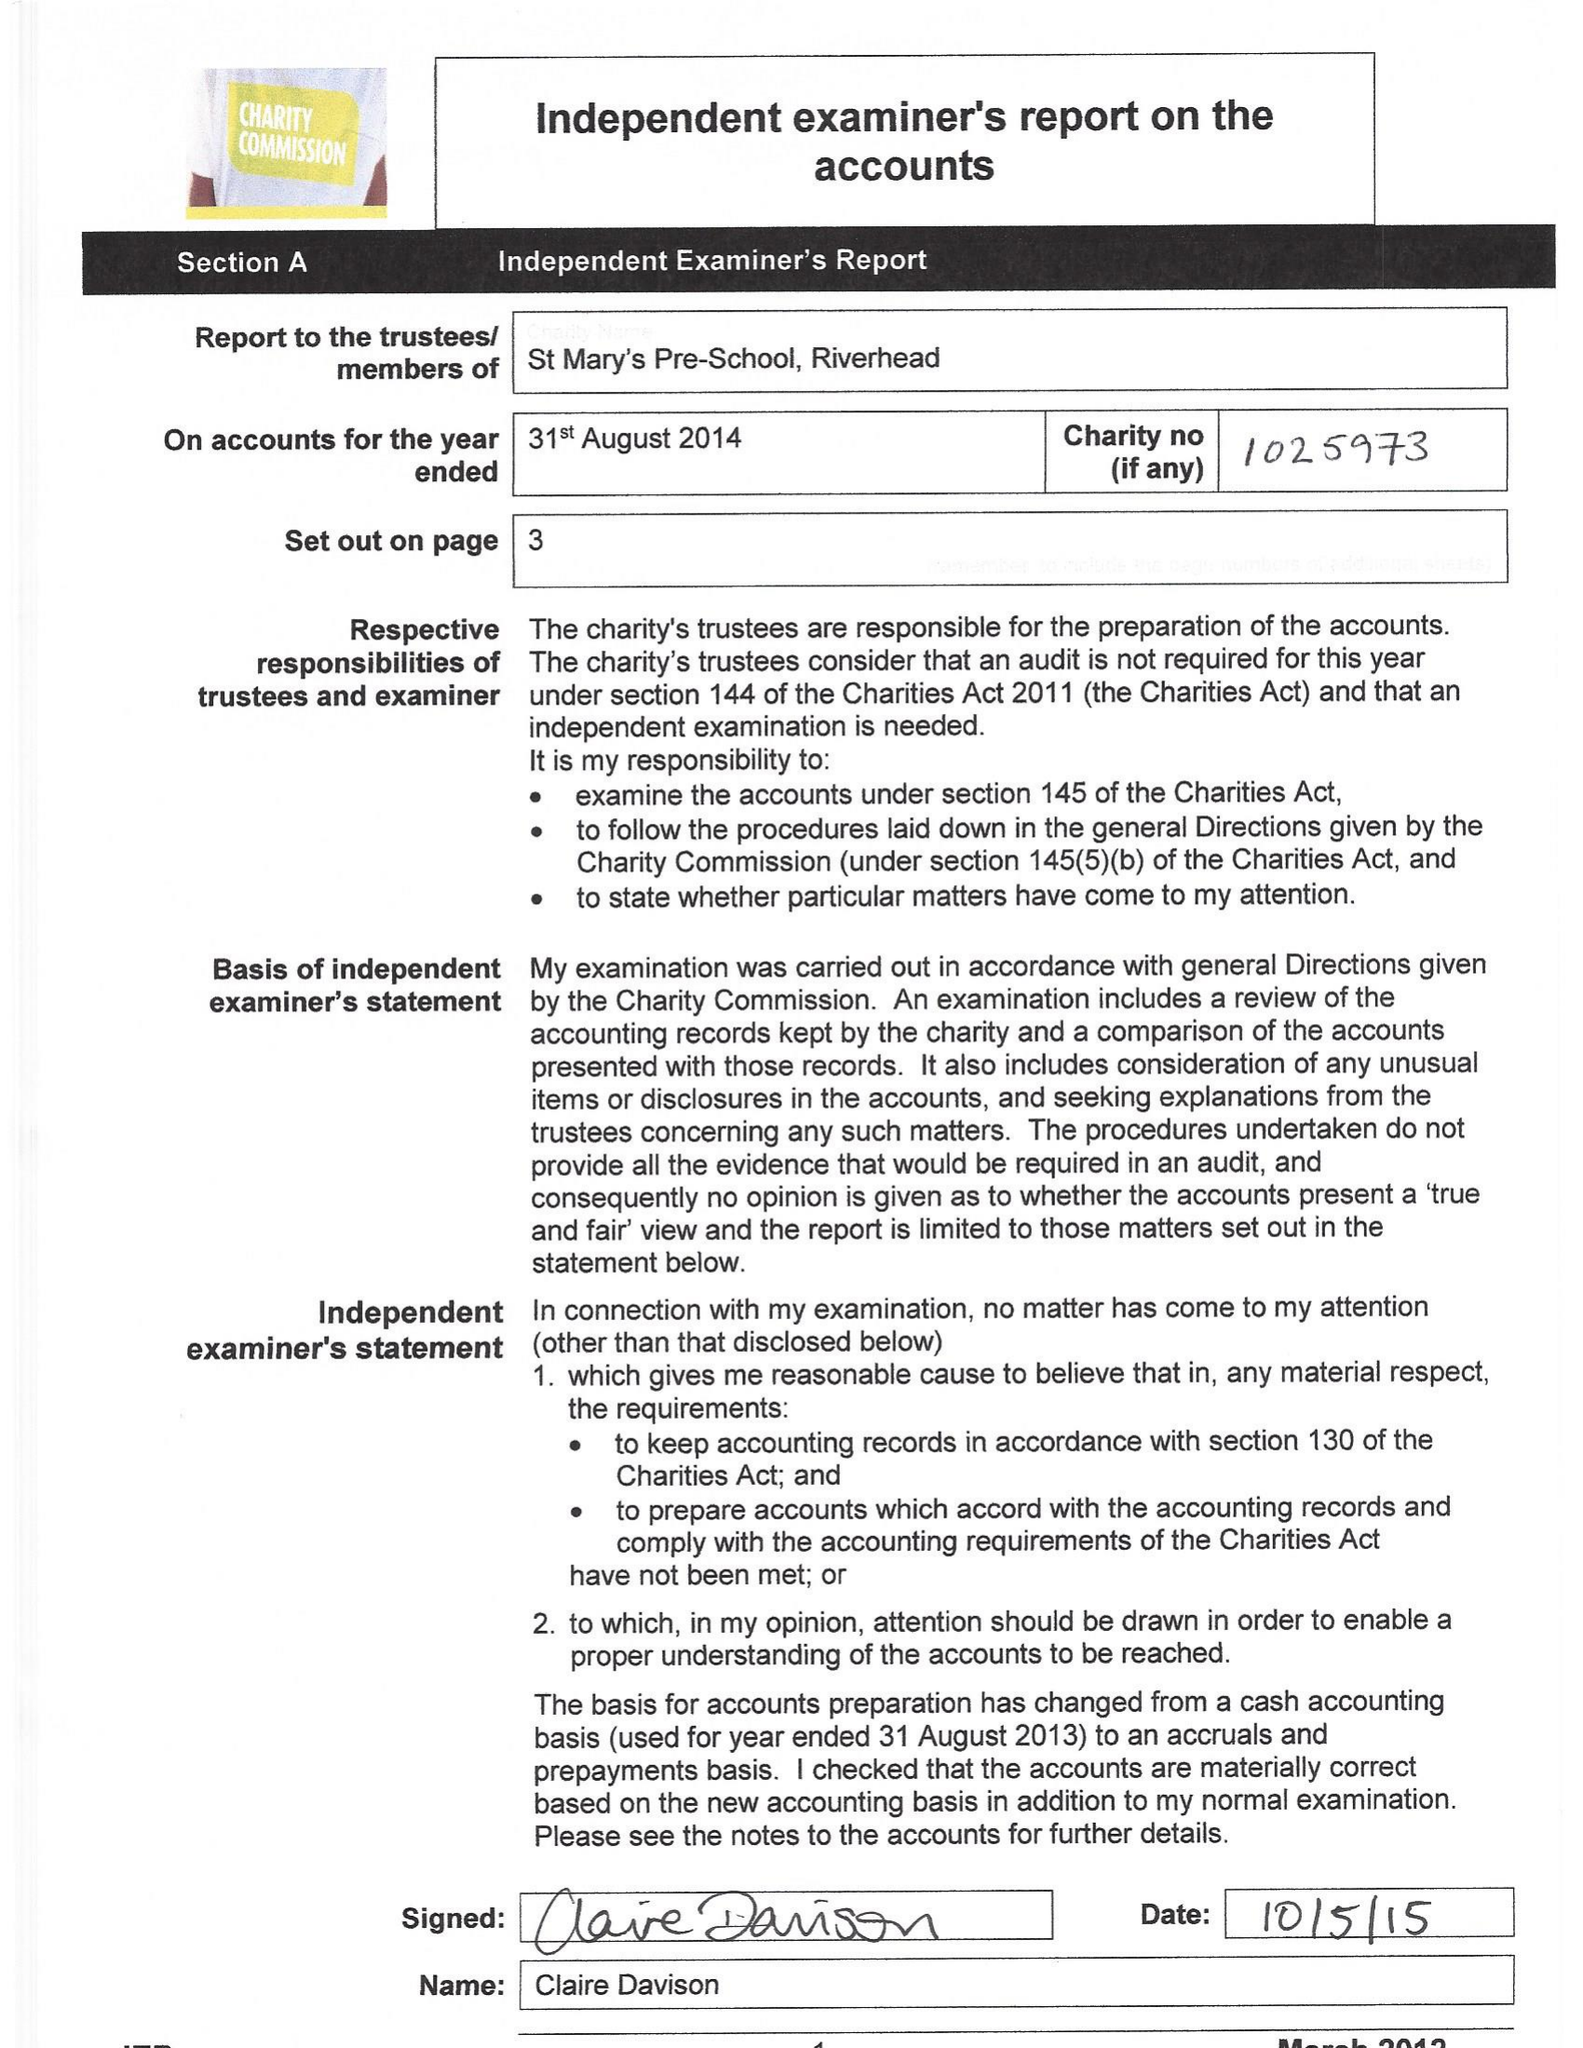What is the value for the charity_name?
Answer the question using a single word or phrase. St Mary's Playgroup (Riverhead) 